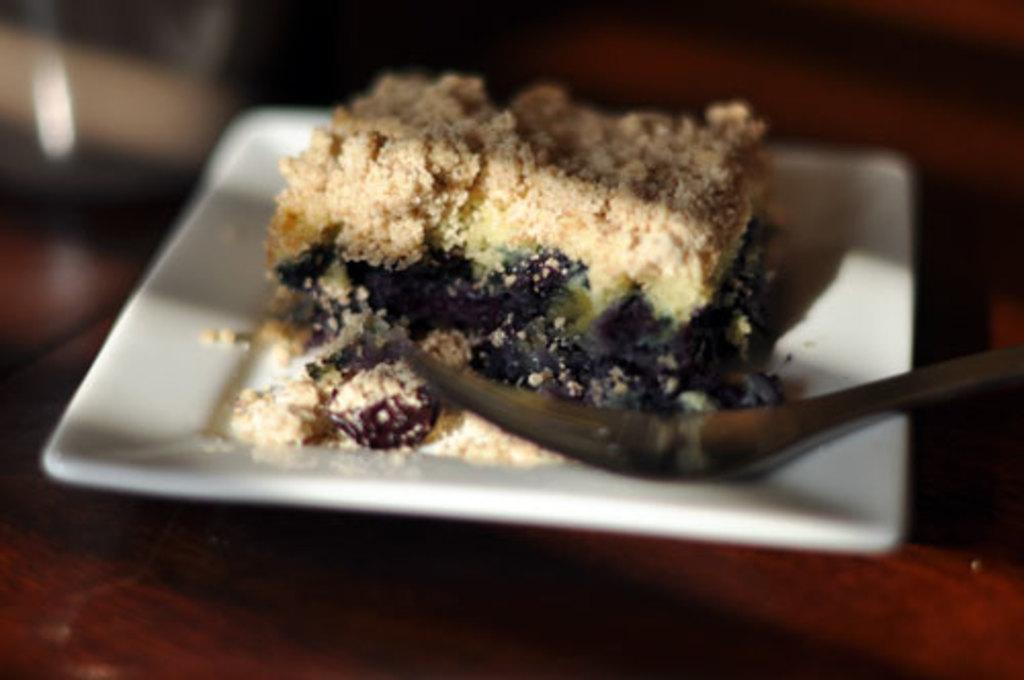What is on the wooden surface in the image? There is a plate in the image. What is the plate resting on? The plate is on a wooden surface. What is on the plate? There is food on the plate, and a fork is also present. Can you describe the top part of the image? The top part of the image is blurry. What type of chicken is the person thinking about in the image? There is no person or chicken present in the image; it only features a plate with food and a fork on a wooden surface. 